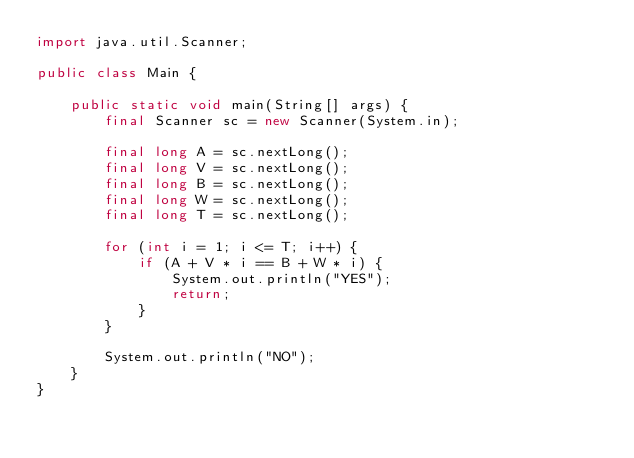Convert code to text. <code><loc_0><loc_0><loc_500><loc_500><_Java_>import java.util.Scanner;

public class Main {

    public static void main(String[] args) {
        final Scanner sc = new Scanner(System.in);

        final long A = sc.nextLong();
        final long V = sc.nextLong();
        final long B = sc.nextLong();
        final long W = sc.nextLong();
        final long T = sc.nextLong();

        for (int i = 1; i <= T; i++) {
            if (A + V * i == B + W * i) {
                System.out.println("YES");
                return;
            }
        }

        System.out.println("NO");
    }
}
</code> 